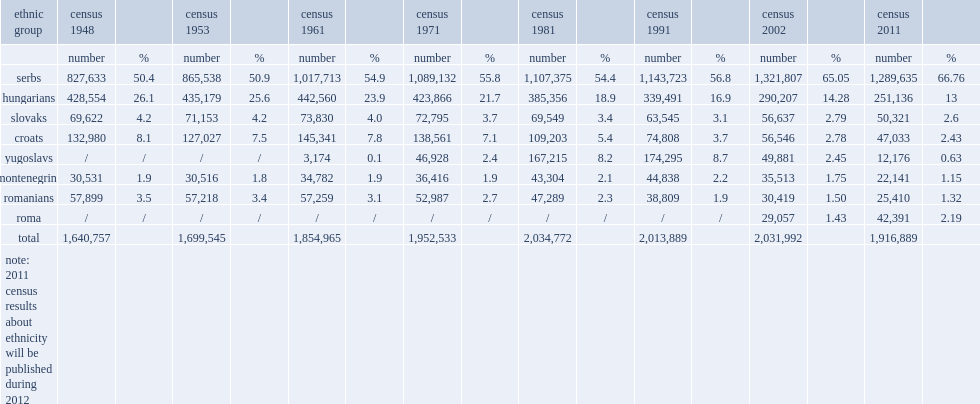How many montenegrins are there in vojvodina? 22141.0. What is the percent of montenegrins' population in vojvodina? 1.15. 